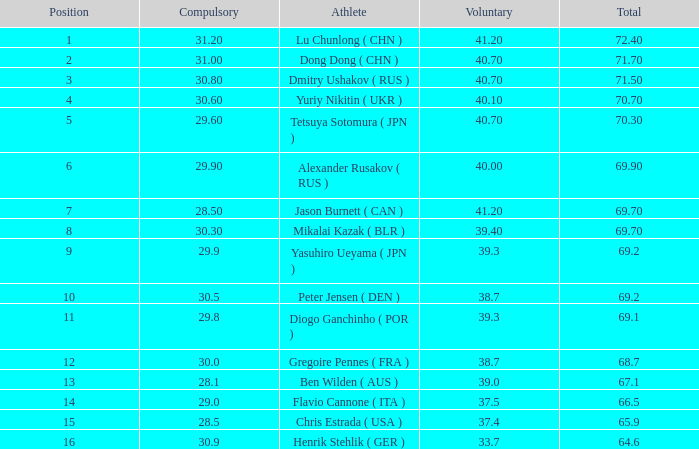What's the total compulsory when the total is more than 69.2 and the voluntary is 38.7? 0.0. 